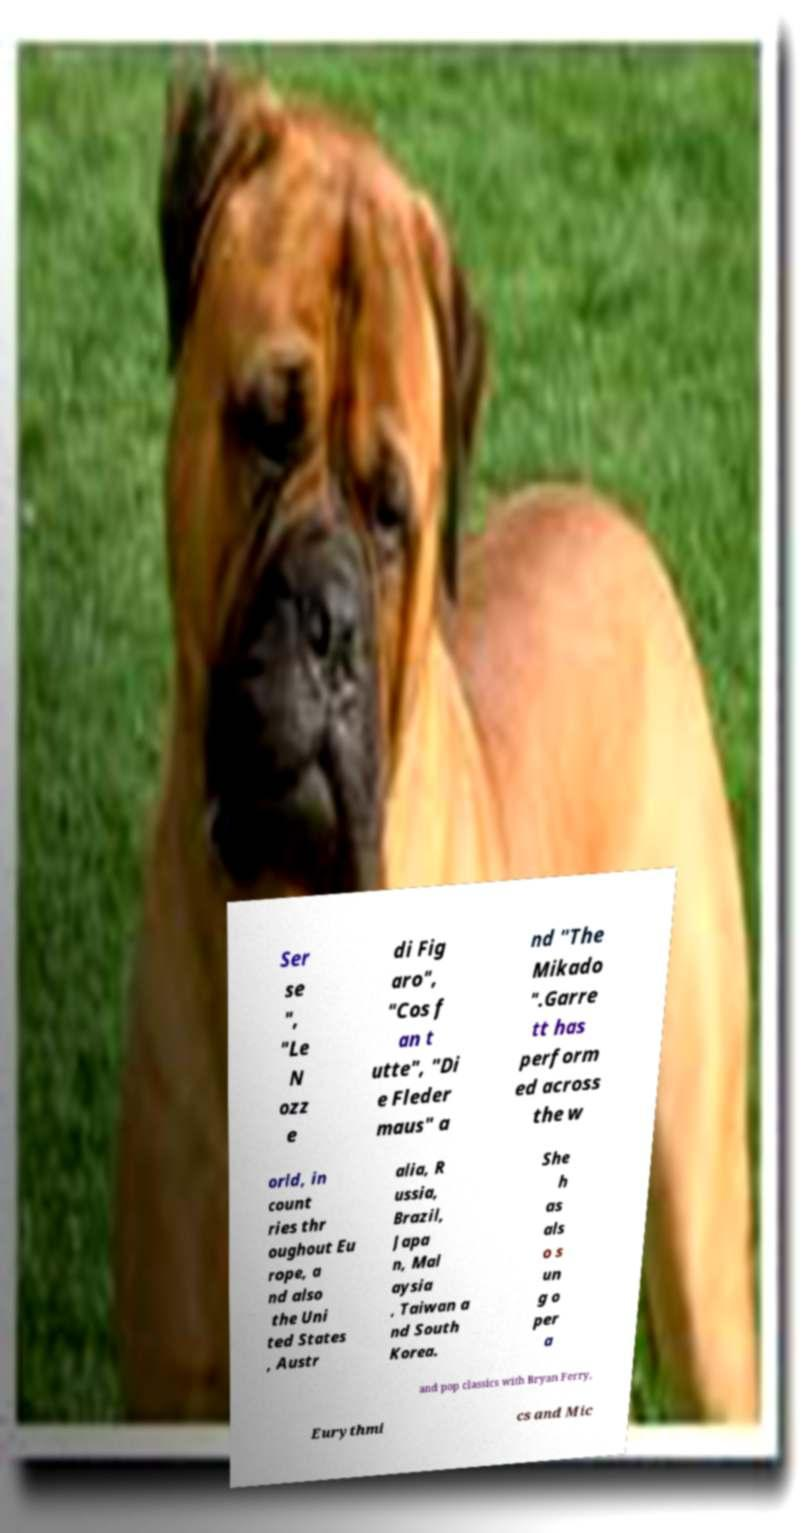For documentation purposes, I need the text within this image transcribed. Could you provide that? Ser se ", "Le N ozz e di Fig aro", "Cos f an t utte", "Di e Fleder maus" a nd "The Mikado ".Garre tt has perform ed across the w orld, in count ries thr oughout Eu rope, a nd also the Uni ted States , Austr alia, R ussia, Brazil, Japa n, Mal aysia , Taiwan a nd South Korea. She h as als o s un g o per a and pop classics with Bryan Ferry, Eurythmi cs and Mic 